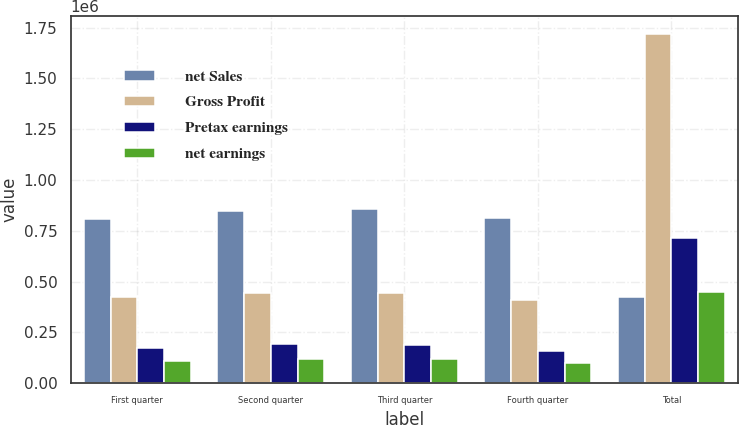<chart> <loc_0><loc_0><loc_500><loc_500><stacked_bar_chart><ecel><fcel>First quarter<fcel>Second quarter<fcel>Third quarter<fcel>Fourth quarter<fcel>Total<nl><fcel>net Sales<fcel>806326<fcel>847596<fcel>858424<fcel>813760<fcel>421880<nl><fcel>Gross Profit<fcel>421880<fcel>442721<fcel>443395<fcel>411449<fcel>1.71944e+06<nl><fcel>Pretax earnings<fcel>175172<fcel>192379<fcel>188643<fcel>157274<fcel>713468<nl><fcel>net earnings<fcel>109048<fcel>121009<fcel>119350<fcel>99229<fcel>448636<nl></chart> 